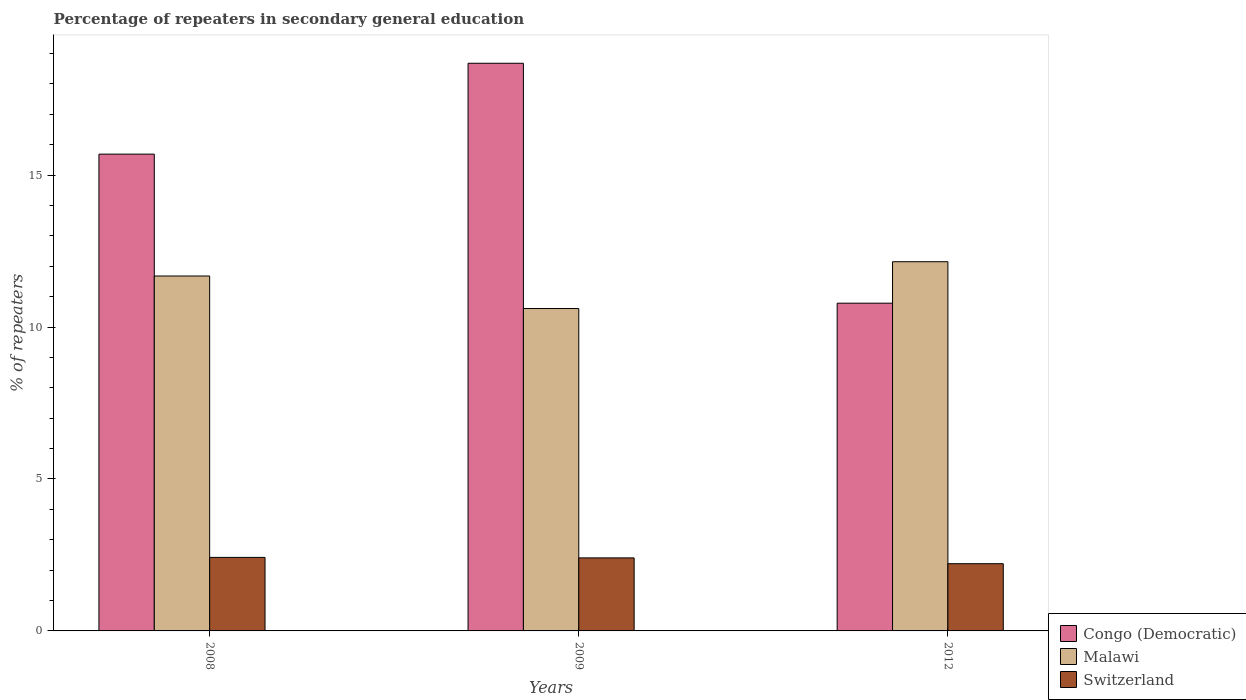How many groups of bars are there?
Give a very brief answer. 3. Are the number of bars on each tick of the X-axis equal?
Keep it short and to the point. Yes. How many bars are there on the 1st tick from the left?
Provide a succinct answer. 3. What is the label of the 2nd group of bars from the left?
Provide a succinct answer. 2009. What is the percentage of repeaters in secondary general education in Switzerland in 2008?
Give a very brief answer. 2.42. Across all years, what is the maximum percentage of repeaters in secondary general education in Switzerland?
Provide a succinct answer. 2.42. Across all years, what is the minimum percentage of repeaters in secondary general education in Malawi?
Offer a terse response. 10.61. In which year was the percentage of repeaters in secondary general education in Malawi maximum?
Your response must be concise. 2012. In which year was the percentage of repeaters in secondary general education in Malawi minimum?
Your answer should be very brief. 2009. What is the total percentage of repeaters in secondary general education in Switzerland in the graph?
Your answer should be compact. 7.03. What is the difference between the percentage of repeaters in secondary general education in Malawi in 2008 and that in 2012?
Give a very brief answer. -0.47. What is the difference between the percentage of repeaters in secondary general education in Congo (Democratic) in 2008 and the percentage of repeaters in secondary general education in Switzerland in 2012?
Ensure brevity in your answer.  13.48. What is the average percentage of repeaters in secondary general education in Switzerland per year?
Give a very brief answer. 2.34. In the year 2012, what is the difference between the percentage of repeaters in secondary general education in Malawi and percentage of repeaters in secondary general education in Switzerland?
Keep it short and to the point. 9.94. What is the ratio of the percentage of repeaters in secondary general education in Congo (Democratic) in 2008 to that in 2009?
Offer a terse response. 0.84. What is the difference between the highest and the second highest percentage of repeaters in secondary general education in Switzerland?
Make the answer very short. 0.02. What is the difference between the highest and the lowest percentage of repeaters in secondary general education in Congo (Democratic)?
Give a very brief answer. 7.9. In how many years, is the percentage of repeaters in secondary general education in Switzerland greater than the average percentage of repeaters in secondary general education in Switzerland taken over all years?
Offer a terse response. 2. What does the 2nd bar from the left in 2009 represents?
Give a very brief answer. Malawi. What does the 2nd bar from the right in 2009 represents?
Provide a succinct answer. Malawi. Is it the case that in every year, the sum of the percentage of repeaters in secondary general education in Switzerland and percentage of repeaters in secondary general education in Congo (Democratic) is greater than the percentage of repeaters in secondary general education in Malawi?
Provide a short and direct response. Yes. How many bars are there?
Your answer should be very brief. 9. Are all the bars in the graph horizontal?
Ensure brevity in your answer.  No. How many years are there in the graph?
Your answer should be compact. 3. What is the difference between two consecutive major ticks on the Y-axis?
Your response must be concise. 5. Where does the legend appear in the graph?
Your response must be concise. Bottom right. How many legend labels are there?
Your response must be concise. 3. What is the title of the graph?
Offer a terse response. Percentage of repeaters in secondary general education. Does "Greece" appear as one of the legend labels in the graph?
Provide a short and direct response. No. What is the label or title of the X-axis?
Make the answer very short. Years. What is the label or title of the Y-axis?
Your answer should be compact. % of repeaters. What is the % of repeaters in Congo (Democratic) in 2008?
Keep it short and to the point. 15.69. What is the % of repeaters of Malawi in 2008?
Your response must be concise. 11.68. What is the % of repeaters of Switzerland in 2008?
Keep it short and to the point. 2.42. What is the % of repeaters in Congo (Democratic) in 2009?
Provide a succinct answer. 18.68. What is the % of repeaters in Malawi in 2009?
Give a very brief answer. 10.61. What is the % of repeaters of Switzerland in 2009?
Ensure brevity in your answer.  2.4. What is the % of repeaters of Congo (Democratic) in 2012?
Offer a very short reply. 10.79. What is the % of repeaters in Malawi in 2012?
Keep it short and to the point. 12.15. What is the % of repeaters of Switzerland in 2012?
Your answer should be compact. 2.21. Across all years, what is the maximum % of repeaters in Congo (Democratic)?
Your answer should be very brief. 18.68. Across all years, what is the maximum % of repeaters in Malawi?
Offer a terse response. 12.15. Across all years, what is the maximum % of repeaters of Switzerland?
Your response must be concise. 2.42. Across all years, what is the minimum % of repeaters of Congo (Democratic)?
Ensure brevity in your answer.  10.79. Across all years, what is the minimum % of repeaters of Malawi?
Keep it short and to the point. 10.61. Across all years, what is the minimum % of repeaters of Switzerland?
Provide a short and direct response. 2.21. What is the total % of repeaters in Congo (Democratic) in the graph?
Provide a succinct answer. 45.16. What is the total % of repeaters of Malawi in the graph?
Your answer should be compact. 34.44. What is the total % of repeaters of Switzerland in the graph?
Keep it short and to the point. 7.03. What is the difference between the % of repeaters in Congo (Democratic) in 2008 and that in 2009?
Ensure brevity in your answer.  -2.99. What is the difference between the % of repeaters in Malawi in 2008 and that in 2009?
Offer a terse response. 1.07. What is the difference between the % of repeaters of Switzerland in 2008 and that in 2009?
Make the answer very short. 0.02. What is the difference between the % of repeaters in Congo (Democratic) in 2008 and that in 2012?
Provide a short and direct response. 4.9. What is the difference between the % of repeaters of Malawi in 2008 and that in 2012?
Offer a very short reply. -0.47. What is the difference between the % of repeaters of Switzerland in 2008 and that in 2012?
Offer a terse response. 0.21. What is the difference between the % of repeaters of Congo (Democratic) in 2009 and that in 2012?
Provide a short and direct response. 7.9. What is the difference between the % of repeaters in Malawi in 2009 and that in 2012?
Give a very brief answer. -1.54. What is the difference between the % of repeaters in Switzerland in 2009 and that in 2012?
Your answer should be very brief. 0.19. What is the difference between the % of repeaters in Congo (Democratic) in 2008 and the % of repeaters in Malawi in 2009?
Ensure brevity in your answer.  5.08. What is the difference between the % of repeaters in Congo (Democratic) in 2008 and the % of repeaters in Switzerland in 2009?
Provide a short and direct response. 13.29. What is the difference between the % of repeaters of Malawi in 2008 and the % of repeaters of Switzerland in 2009?
Provide a succinct answer. 9.28. What is the difference between the % of repeaters in Congo (Democratic) in 2008 and the % of repeaters in Malawi in 2012?
Provide a short and direct response. 3.54. What is the difference between the % of repeaters in Congo (Democratic) in 2008 and the % of repeaters in Switzerland in 2012?
Give a very brief answer. 13.48. What is the difference between the % of repeaters of Malawi in 2008 and the % of repeaters of Switzerland in 2012?
Your answer should be very brief. 9.47. What is the difference between the % of repeaters of Congo (Democratic) in 2009 and the % of repeaters of Malawi in 2012?
Your response must be concise. 6.53. What is the difference between the % of repeaters of Congo (Democratic) in 2009 and the % of repeaters of Switzerland in 2012?
Give a very brief answer. 16.47. What is the difference between the % of repeaters in Malawi in 2009 and the % of repeaters in Switzerland in 2012?
Your answer should be compact. 8.4. What is the average % of repeaters of Congo (Democratic) per year?
Make the answer very short. 15.05. What is the average % of repeaters of Malawi per year?
Provide a succinct answer. 11.48. What is the average % of repeaters of Switzerland per year?
Ensure brevity in your answer.  2.34. In the year 2008, what is the difference between the % of repeaters in Congo (Democratic) and % of repeaters in Malawi?
Provide a succinct answer. 4.01. In the year 2008, what is the difference between the % of repeaters in Congo (Democratic) and % of repeaters in Switzerland?
Ensure brevity in your answer.  13.27. In the year 2008, what is the difference between the % of repeaters of Malawi and % of repeaters of Switzerland?
Provide a short and direct response. 9.26. In the year 2009, what is the difference between the % of repeaters of Congo (Democratic) and % of repeaters of Malawi?
Your response must be concise. 8.07. In the year 2009, what is the difference between the % of repeaters in Congo (Democratic) and % of repeaters in Switzerland?
Give a very brief answer. 16.28. In the year 2009, what is the difference between the % of repeaters in Malawi and % of repeaters in Switzerland?
Give a very brief answer. 8.21. In the year 2012, what is the difference between the % of repeaters in Congo (Democratic) and % of repeaters in Malawi?
Your response must be concise. -1.36. In the year 2012, what is the difference between the % of repeaters of Congo (Democratic) and % of repeaters of Switzerland?
Make the answer very short. 8.57. In the year 2012, what is the difference between the % of repeaters of Malawi and % of repeaters of Switzerland?
Your answer should be very brief. 9.94. What is the ratio of the % of repeaters of Congo (Democratic) in 2008 to that in 2009?
Offer a terse response. 0.84. What is the ratio of the % of repeaters of Malawi in 2008 to that in 2009?
Offer a terse response. 1.1. What is the ratio of the % of repeaters of Congo (Democratic) in 2008 to that in 2012?
Make the answer very short. 1.45. What is the ratio of the % of repeaters in Malawi in 2008 to that in 2012?
Ensure brevity in your answer.  0.96. What is the ratio of the % of repeaters of Switzerland in 2008 to that in 2012?
Give a very brief answer. 1.09. What is the ratio of the % of repeaters in Congo (Democratic) in 2009 to that in 2012?
Ensure brevity in your answer.  1.73. What is the ratio of the % of repeaters of Malawi in 2009 to that in 2012?
Your response must be concise. 0.87. What is the ratio of the % of repeaters in Switzerland in 2009 to that in 2012?
Keep it short and to the point. 1.09. What is the difference between the highest and the second highest % of repeaters in Congo (Democratic)?
Provide a succinct answer. 2.99. What is the difference between the highest and the second highest % of repeaters in Malawi?
Provide a short and direct response. 0.47. What is the difference between the highest and the second highest % of repeaters in Switzerland?
Make the answer very short. 0.02. What is the difference between the highest and the lowest % of repeaters in Congo (Democratic)?
Provide a short and direct response. 7.9. What is the difference between the highest and the lowest % of repeaters of Malawi?
Ensure brevity in your answer.  1.54. What is the difference between the highest and the lowest % of repeaters of Switzerland?
Offer a very short reply. 0.21. 